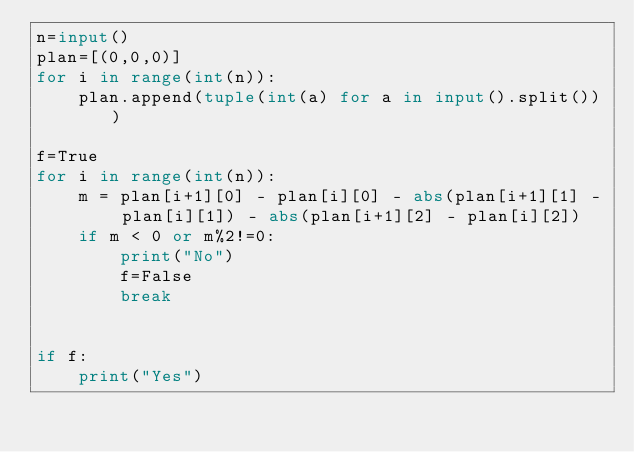Convert code to text. <code><loc_0><loc_0><loc_500><loc_500><_Python_>n=input()
plan=[(0,0,0)]
for i in range(int(n)):
    plan.append(tuple(int(a) for a in input().split()))

f=True
for i in range(int(n)):
    m = plan[i+1][0] - plan[i][0] - abs(plan[i+1][1] - plan[i][1]) - abs(plan[i+1][2] - plan[i][2]) 
    if m < 0 or m%2!=0:
        print("No")
        f=False
        break


if f:
    print("Yes")
</code> 